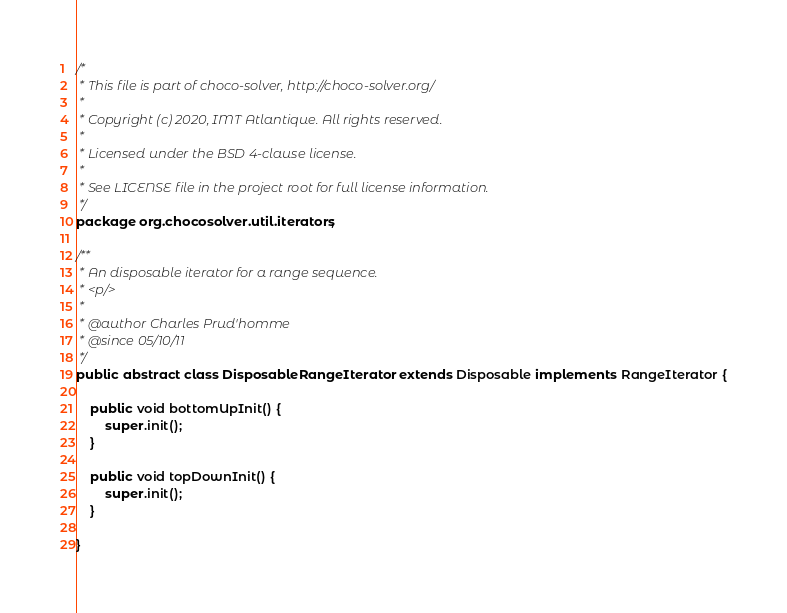<code> <loc_0><loc_0><loc_500><loc_500><_Java_>/*
 * This file is part of choco-solver, http://choco-solver.org/
 *
 * Copyright (c) 2020, IMT Atlantique. All rights reserved.
 *
 * Licensed under the BSD 4-clause license.
 *
 * See LICENSE file in the project root for full license information.
 */
package org.chocosolver.util.iterators;

/**
 * An disposable iterator for a range sequence.
 * <p/>
 *
 * @author Charles Prud'homme
 * @since 05/10/11
 */
public abstract class DisposableRangeIterator extends Disposable implements RangeIterator {

    public void bottomUpInit() {
        super.init();
    }

    public void topDownInit() {
        super.init();
    }

}
</code> 